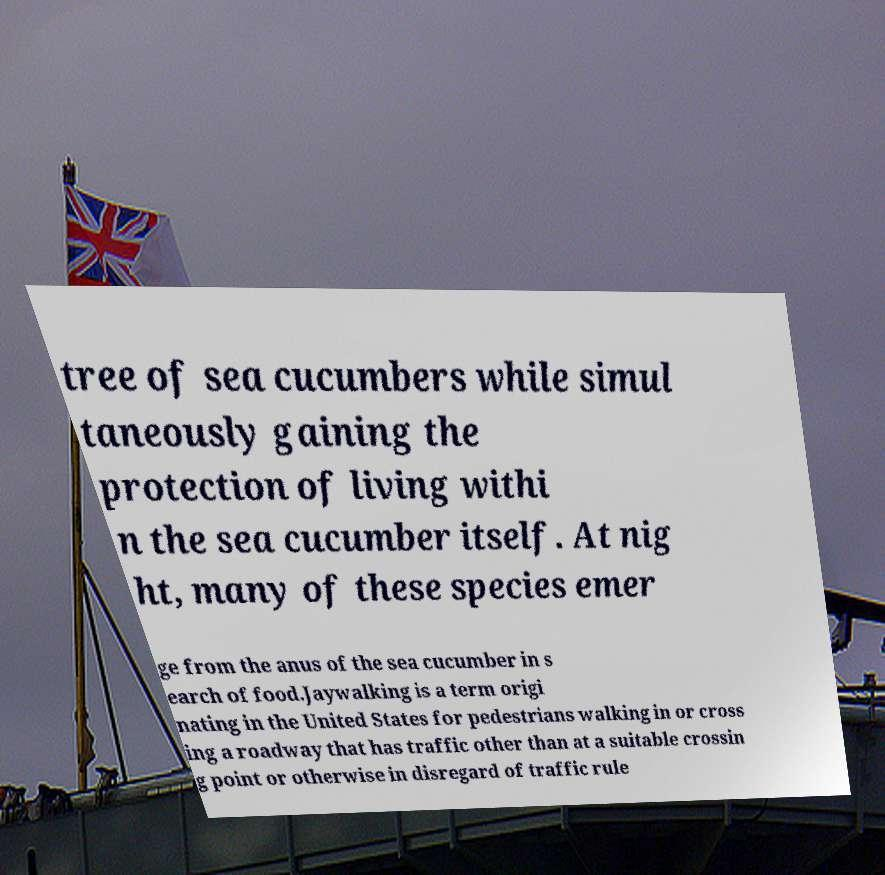Please identify and transcribe the text found in this image. tree of sea cucumbers while simul taneously gaining the protection of living withi n the sea cucumber itself. At nig ht, many of these species emer ge from the anus of the sea cucumber in s earch of food.Jaywalking is a term origi nating in the United States for pedestrians walking in or cross ing a roadway that has traffic other than at a suitable crossin g point or otherwise in disregard of traffic rule 